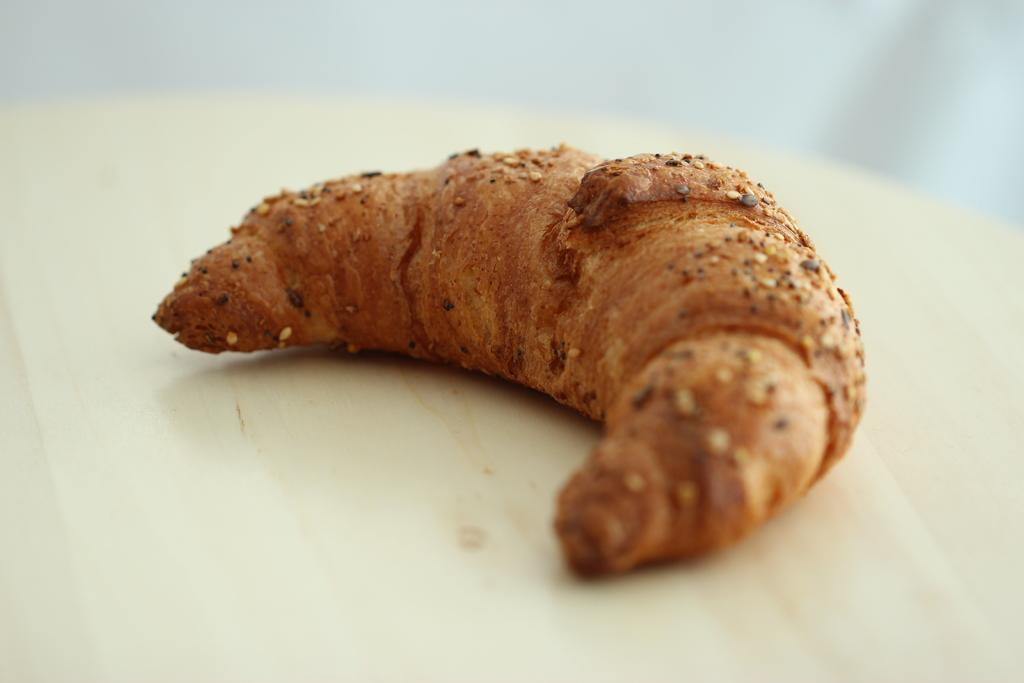What is the main subject of the image? There is a food item in the image. Where is the food item located? The food item is on top of an object. Can you describe the background of the image? The background of the image is blurred. Is there a maid in the image helping to serve the food item? There is no mention of a maid or any person serving the food item in the image. What type of cord is connected to the food item in the image? There is no cord connected to the food item in the image. 